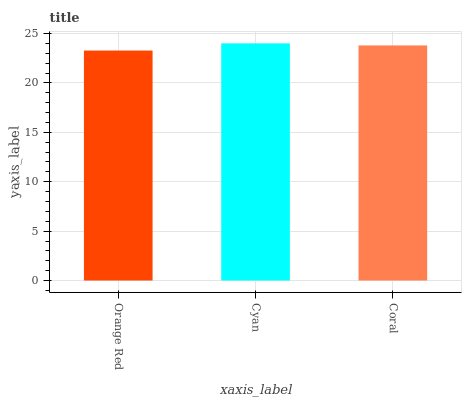Is Orange Red the minimum?
Answer yes or no. Yes. Is Cyan the maximum?
Answer yes or no. Yes. Is Coral the minimum?
Answer yes or no. No. Is Coral the maximum?
Answer yes or no. No. Is Cyan greater than Coral?
Answer yes or no. Yes. Is Coral less than Cyan?
Answer yes or no. Yes. Is Coral greater than Cyan?
Answer yes or no. No. Is Cyan less than Coral?
Answer yes or no. No. Is Coral the high median?
Answer yes or no. Yes. Is Coral the low median?
Answer yes or no. Yes. Is Cyan the high median?
Answer yes or no. No. Is Orange Red the low median?
Answer yes or no. No. 